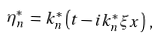<formula> <loc_0><loc_0><loc_500><loc_500>\eta _ { n } ^ { * } \, = \, k _ { n } ^ { * } \left ( t - i k _ { n } ^ { * } \xi x \right ) \, , \,</formula> 